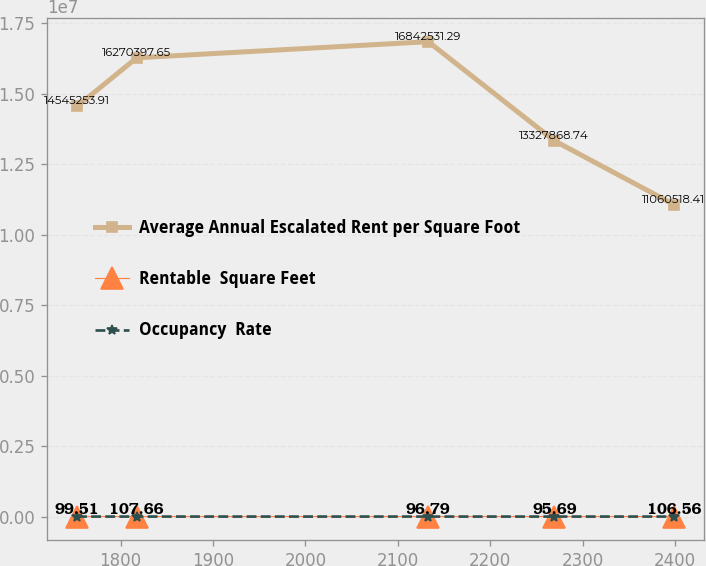Convert chart. <chart><loc_0><loc_0><loc_500><loc_500><line_chart><ecel><fcel>Average Annual Escalated Rent per Square Foot<fcel>Rentable  Square Feet<fcel>Occupancy  Rate<nl><fcel>1752.84<fcel>1.45453e+07<fcel>99.51<fcel>51.58<nl><fcel>1817.45<fcel>1.62704e+07<fcel>107.66<fcel>65.86<nl><fcel>2132.84<fcel>1.68425e+07<fcel>96.79<fcel>57.45<nl><fcel>2269.33<fcel>1.33279e+07<fcel>95.69<fcel>49.79<nl><fcel>2398.94<fcel>1.10605e+07<fcel>106.56<fcel>48<nl></chart> 